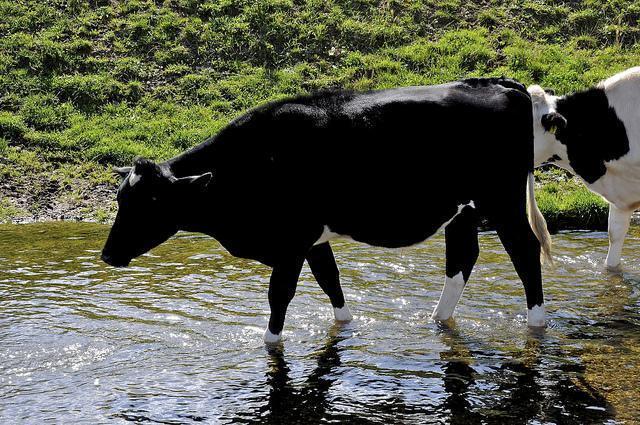How many cows are white?
Give a very brief answer. 1. How many cows are in the photo?
Give a very brief answer. 2. How many motorcycles are there?
Give a very brief answer. 0. 